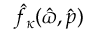<formula> <loc_0><loc_0><loc_500><loc_500>\hat { f } _ { \kappa } ( \hat { \varpi } , \hat { p } )</formula> 